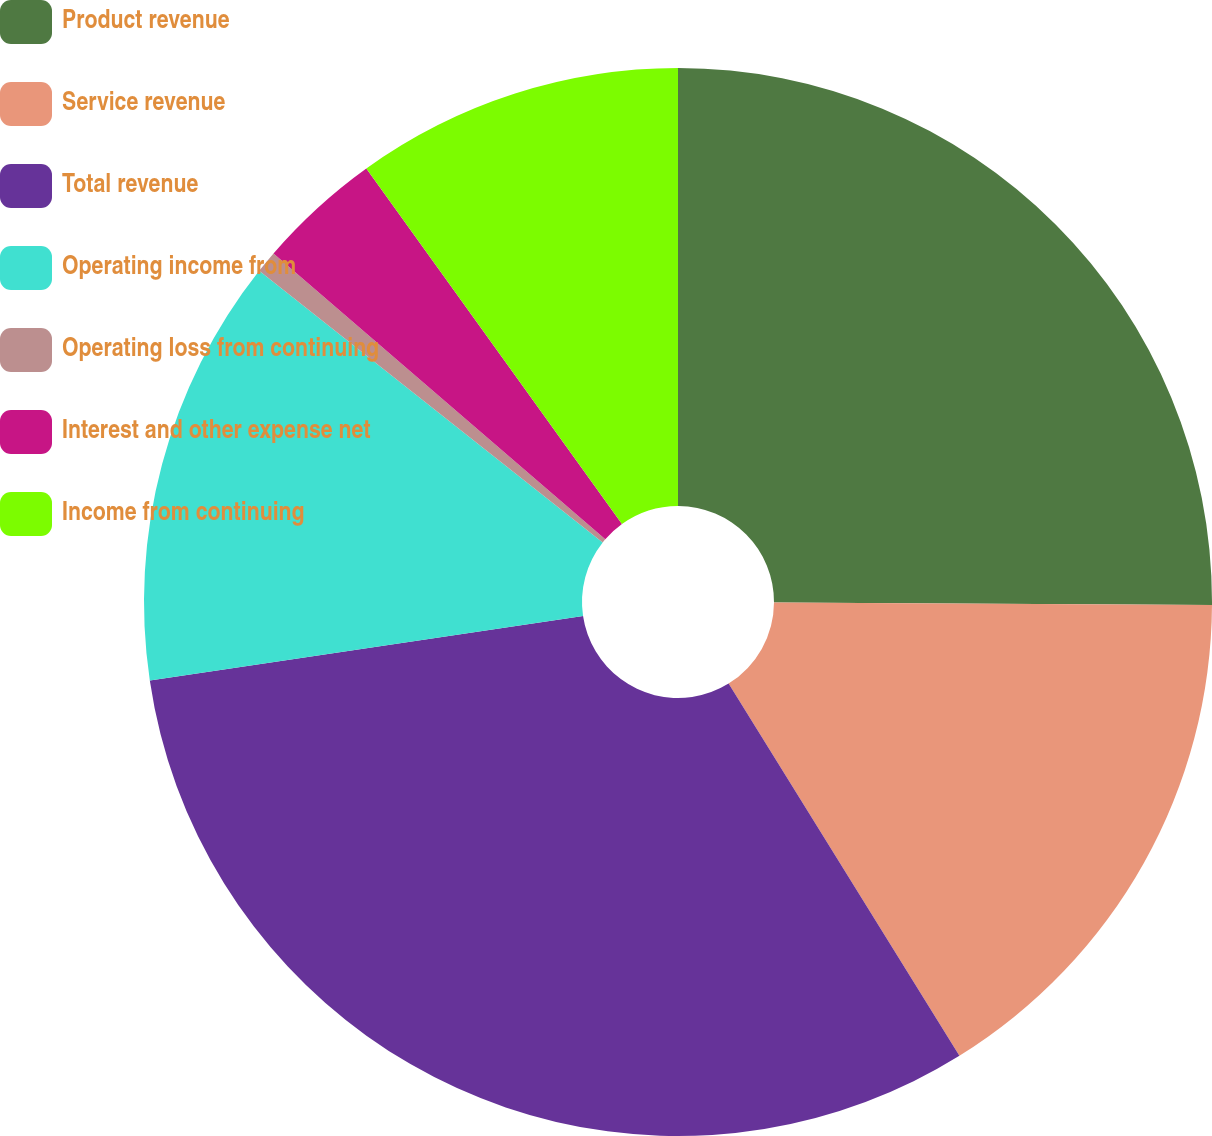Convert chart to OTSL. <chart><loc_0><loc_0><loc_500><loc_500><pie_chart><fcel>Product revenue<fcel>Service revenue<fcel>Total revenue<fcel>Operating income from<fcel>Operating loss from continuing<fcel>Interest and other expense net<fcel>Income from continuing<nl><fcel>25.09%<fcel>16.08%<fcel>31.49%<fcel>13.0%<fcel>0.67%<fcel>3.76%<fcel>9.92%<nl></chart> 